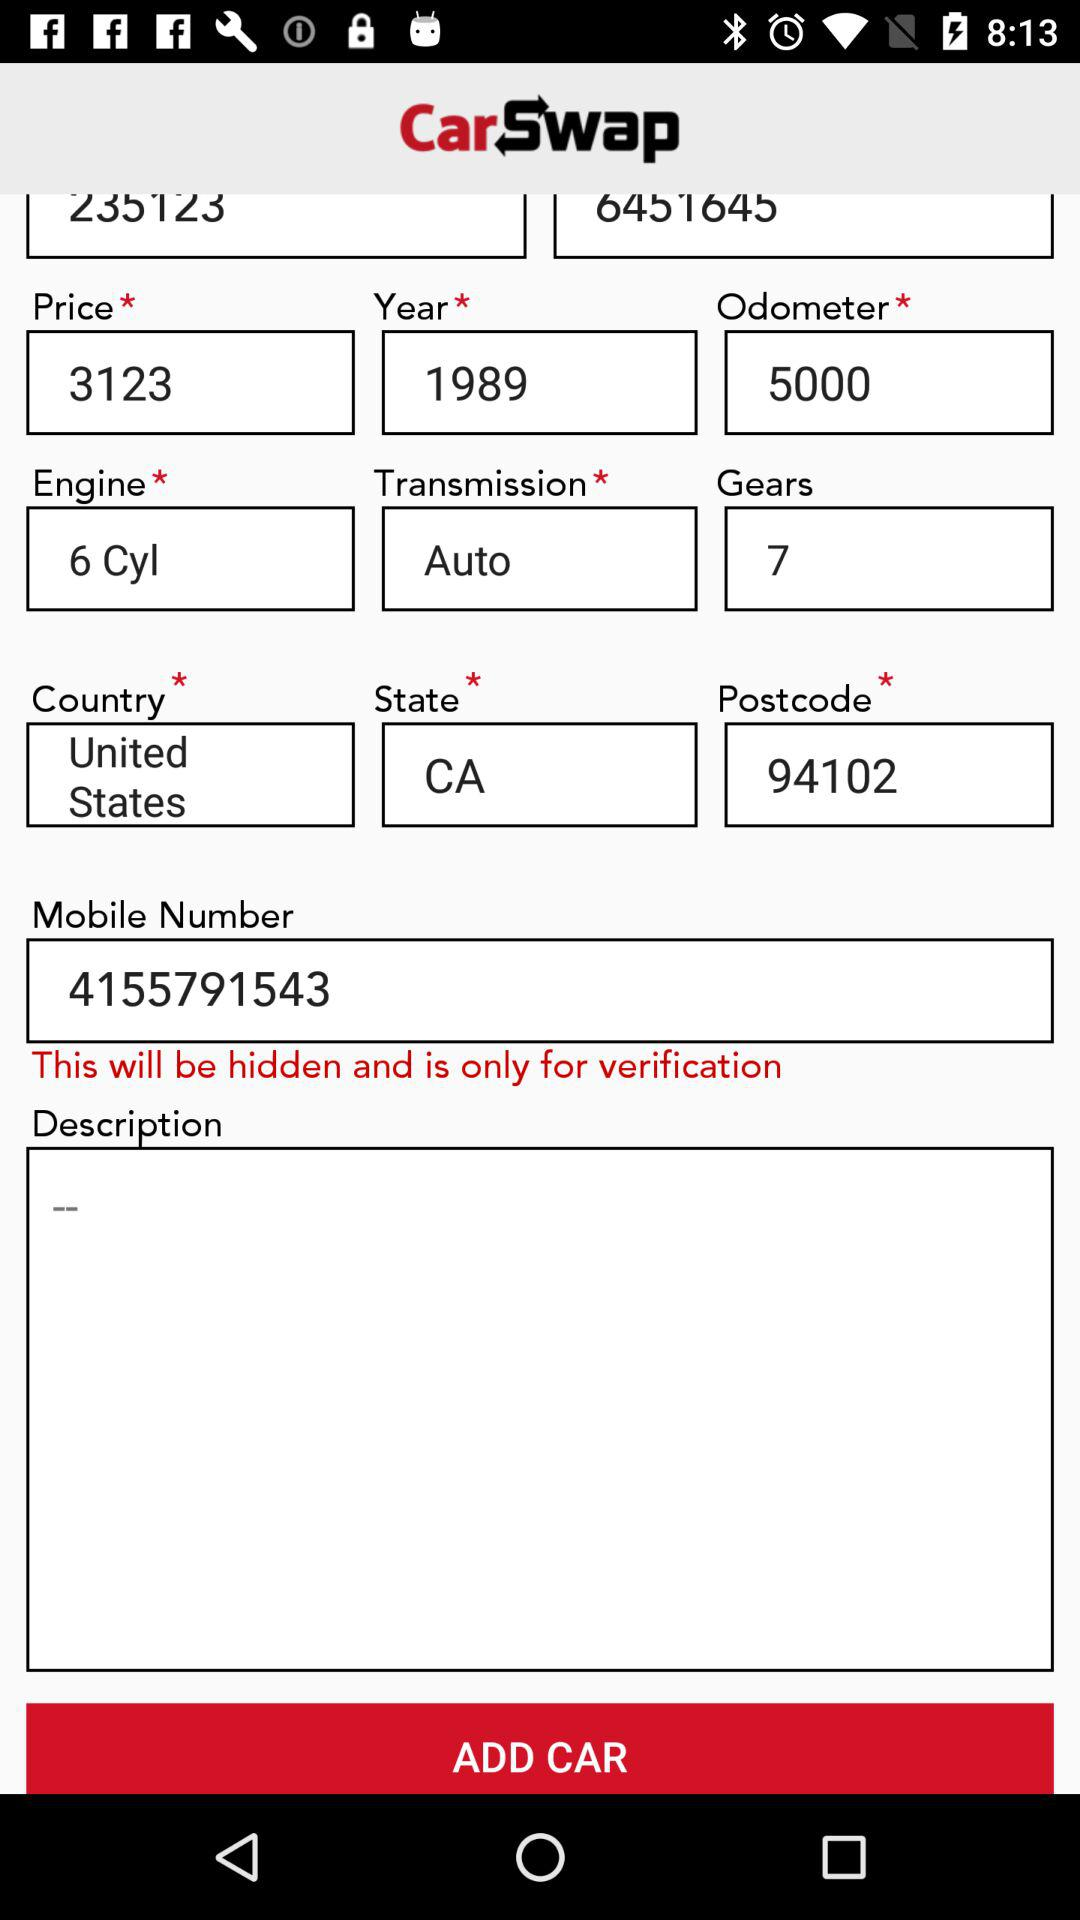What is the country? The country is the United States. 